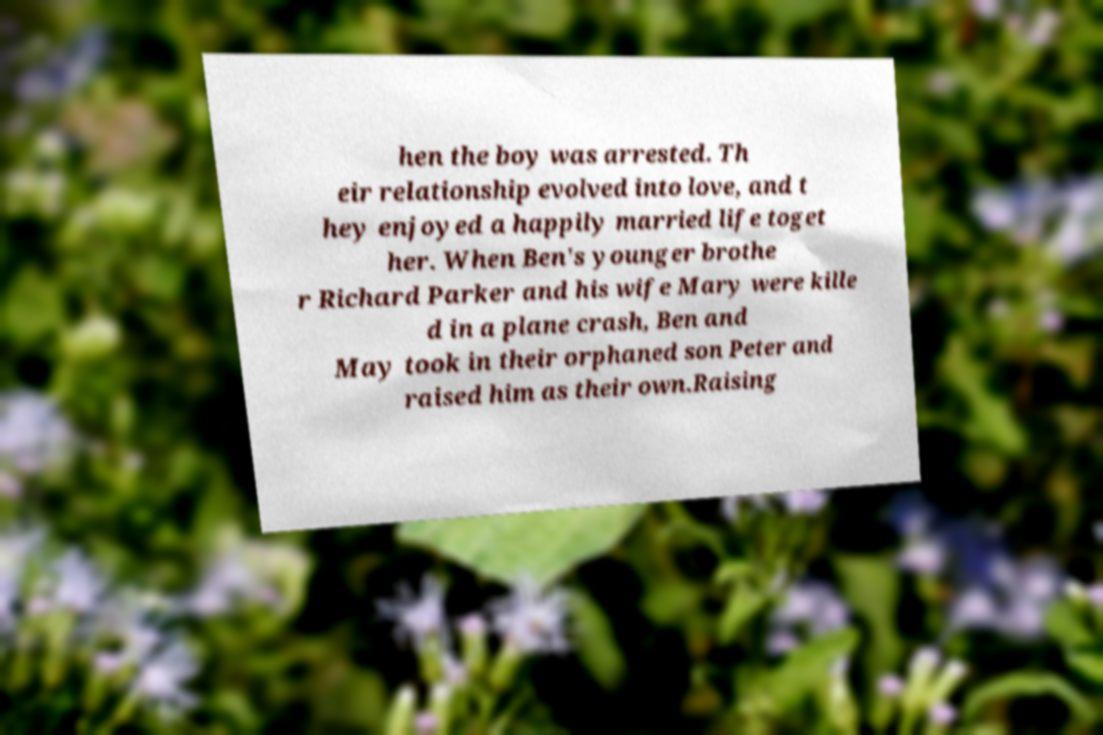Can you accurately transcribe the text from the provided image for me? hen the boy was arrested. Th eir relationship evolved into love, and t hey enjoyed a happily married life toget her. When Ben's younger brothe r Richard Parker and his wife Mary were kille d in a plane crash, Ben and May took in their orphaned son Peter and raised him as their own.Raising 